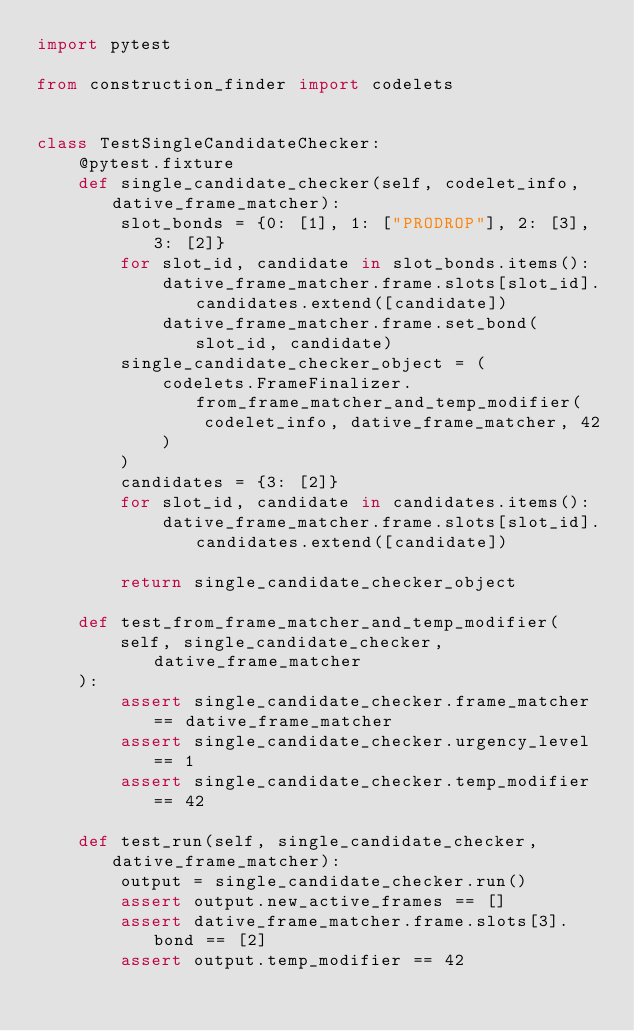Convert code to text. <code><loc_0><loc_0><loc_500><loc_500><_Python_>import pytest

from construction_finder import codelets


class TestSingleCandidateChecker:
    @pytest.fixture
    def single_candidate_checker(self, codelet_info, dative_frame_matcher):
        slot_bonds = {0: [1], 1: ["PRODROP"], 2: [3], 3: [2]}
        for slot_id, candidate in slot_bonds.items():
            dative_frame_matcher.frame.slots[slot_id].candidates.extend([candidate])
            dative_frame_matcher.frame.set_bond(slot_id, candidate)
        single_candidate_checker_object = (
            codelets.FrameFinalizer.from_frame_matcher_and_temp_modifier(
                codelet_info, dative_frame_matcher, 42
            )
        )
        candidates = {3: [2]}
        for slot_id, candidate in candidates.items():
            dative_frame_matcher.frame.slots[slot_id].candidates.extend([candidate])

        return single_candidate_checker_object

    def test_from_frame_matcher_and_temp_modifier(
        self, single_candidate_checker, dative_frame_matcher
    ):
        assert single_candidate_checker.frame_matcher == dative_frame_matcher
        assert single_candidate_checker.urgency_level == 1
        assert single_candidate_checker.temp_modifier == 42

    def test_run(self, single_candidate_checker, dative_frame_matcher):
        output = single_candidate_checker.run()
        assert output.new_active_frames == []
        assert dative_frame_matcher.frame.slots[3].bond == [2]
        assert output.temp_modifier == 42
</code> 